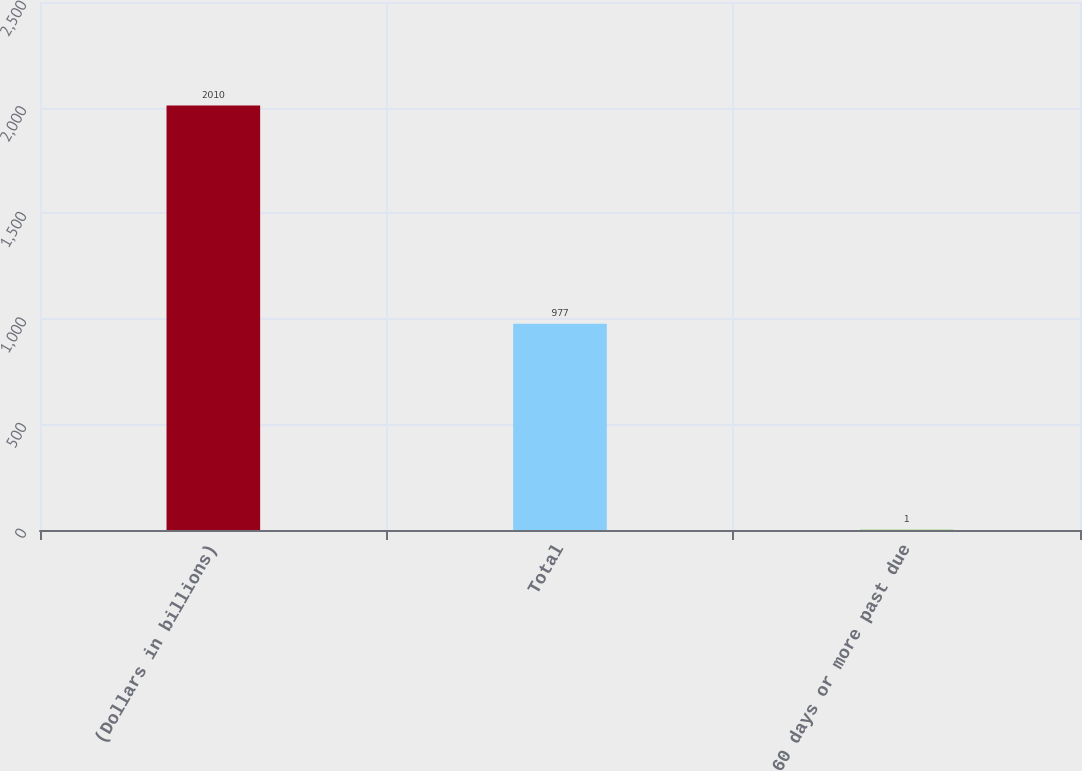Convert chart to OTSL. <chart><loc_0><loc_0><loc_500><loc_500><bar_chart><fcel>(Dollars in billions)<fcel>Total<fcel>60 days or more past due<nl><fcel>2010<fcel>977<fcel>1<nl></chart> 